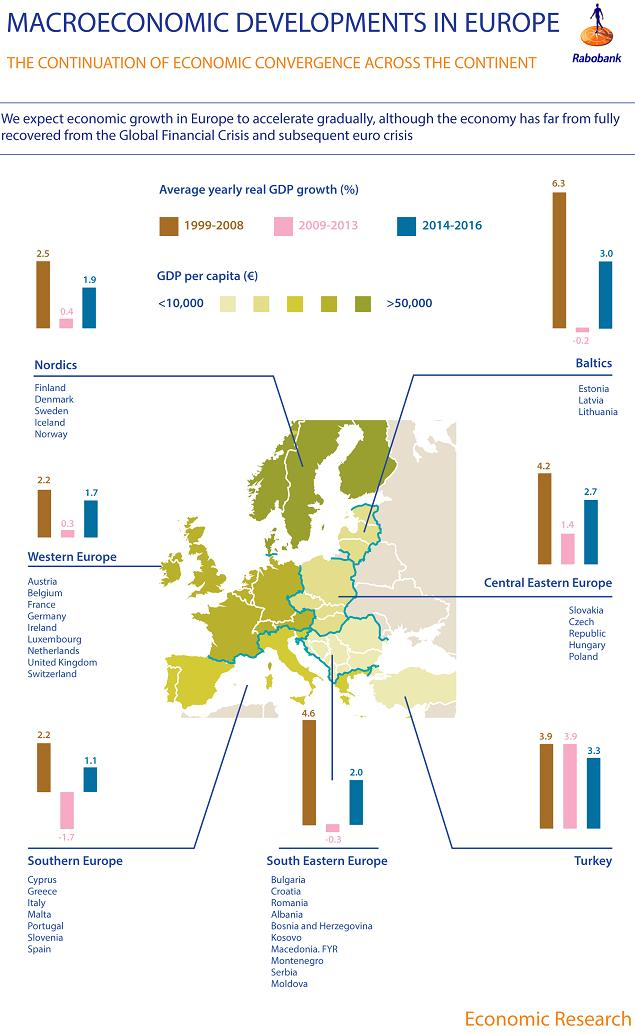Identify some key points in this picture. The Baltics region had the highest average yearly GDP growth during the years 1999 to 2008. During the 2009-2013 period, the highest negative GDP growth was recorded at -1.7%. According to the data provided, Turkey had the highest average yearly real GDP growth in the period of 2009-2013. According to data from the year 2014 to 2016, the region with the highest average yearly GDP growth was Turkey. During the period of 2009-2013, several regions experienced negative GDP growth, including the Baltics, Southern Europe, and South Eastern Europe. 